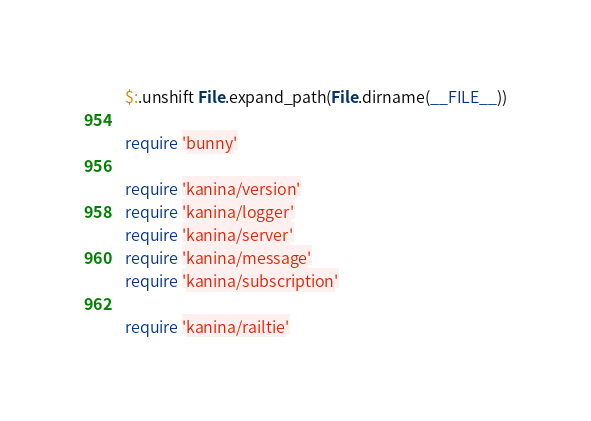Convert code to text. <code><loc_0><loc_0><loc_500><loc_500><_Ruby_>$:.unshift File.expand_path(File.dirname(__FILE__))

require 'bunny'

require 'kanina/version'
require 'kanina/logger'
require 'kanina/server'
require 'kanina/message'
require 'kanina/subscription'

require 'kanina/railtie'
</code> 